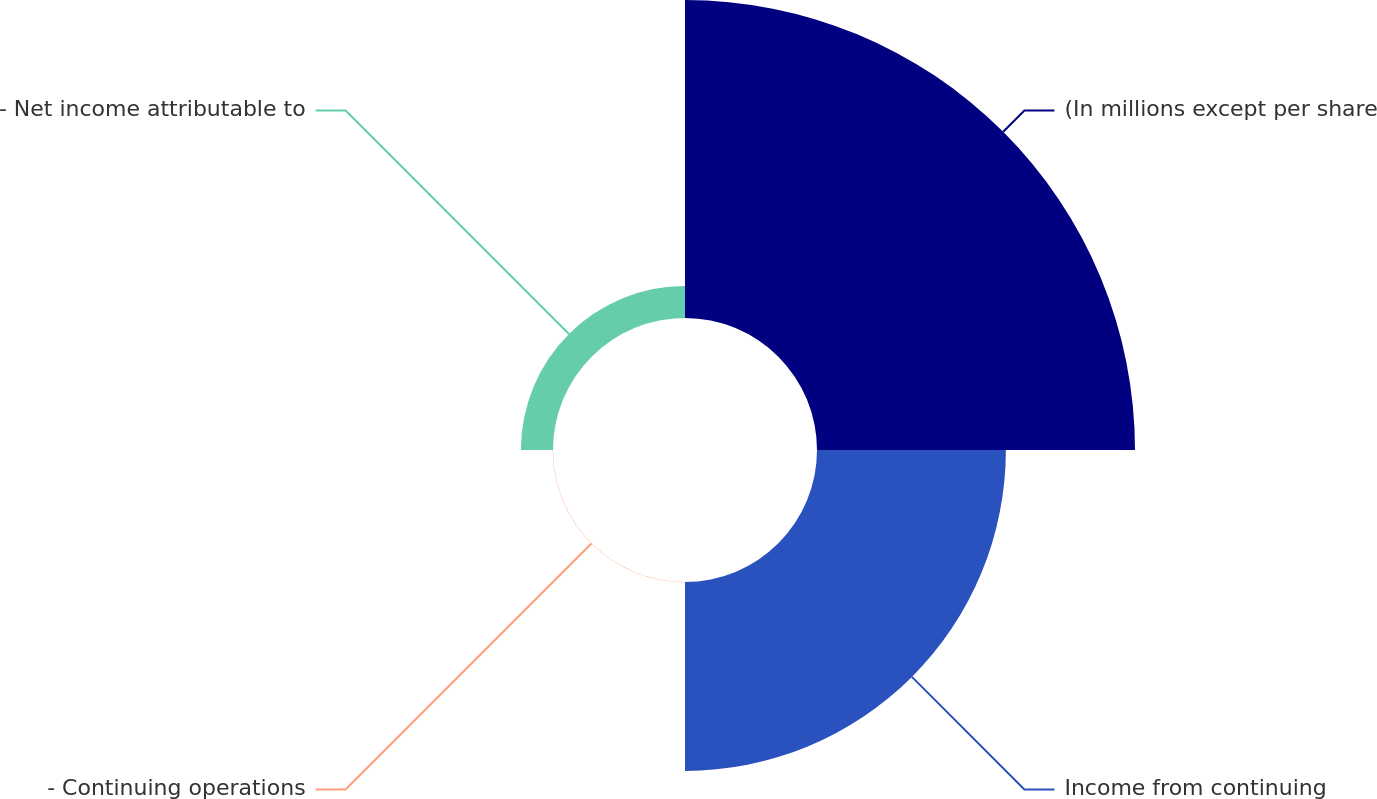Convert chart. <chart><loc_0><loc_0><loc_500><loc_500><pie_chart><fcel>(In millions except per share<fcel>Income from continuing<fcel>- Continuing operations<fcel>- Net income attributable to<nl><fcel>58.96%<fcel>35.02%<fcel>0.06%<fcel>5.95%<nl></chart> 